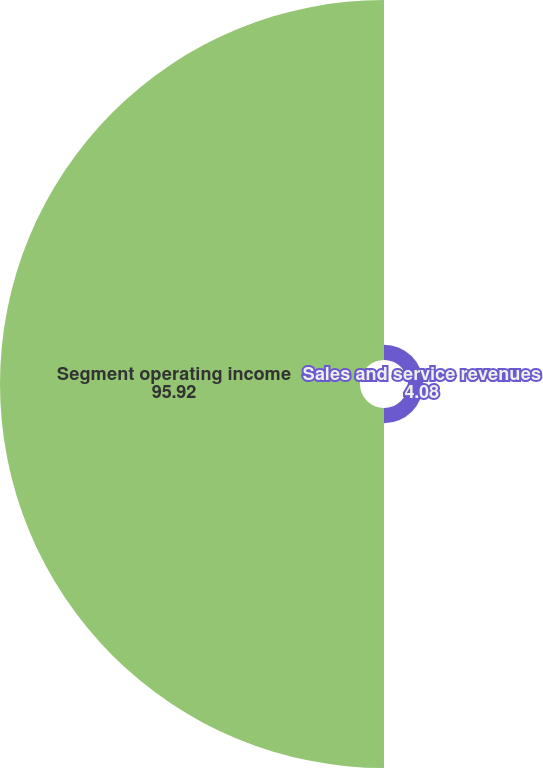<chart> <loc_0><loc_0><loc_500><loc_500><pie_chart><fcel>Sales and service revenues<fcel>Segment operating income<nl><fcel>4.08%<fcel>95.92%<nl></chart> 